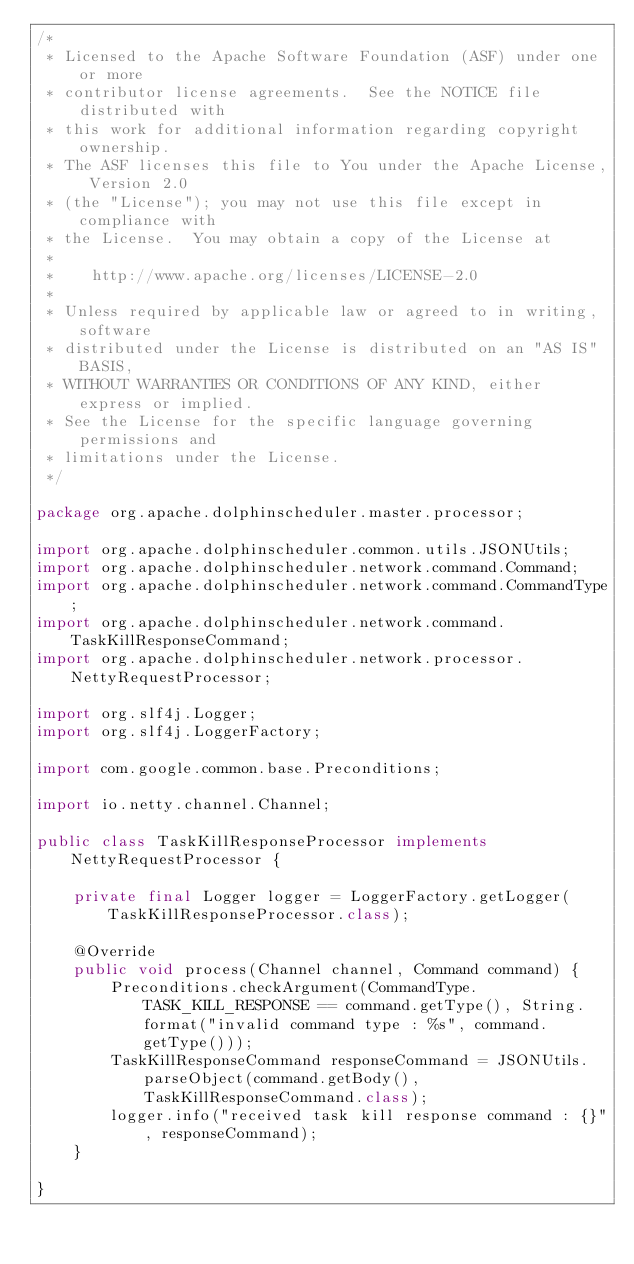<code> <loc_0><loc_0><loc_500><loc_500><_Java_>/*
 * Licensed to the Apache Software Foundation (ASF) under one or more
 * contributor license agreements.  See the NOTICE file distributed with
 * this work for additional information regarding copyright ownership.
 * The ASF licenses this file to You under the Apache License, Version 2.0
 * (the "License"); you may not use this file except in compliance with
 * the License.  You may obtain a copy of the License at
 *
 *    http://www.apache.org/licenses/LICENSE-2.0
 *
 * Unless required by applicable law or agreed to in writing, software
 * distributed under the License is distributed on an "AS IS" BASIS,
 * WITHOUT WARRANTIES OR CONDITIONS OF ANY KIND, either express or implied.
 * See the License for the specific language governing permissions and
 * limitations under the License.
 */

package org.apache.dolphinscheduler.master.processor;

import org.apache.dolphinscheduler.common.utils.JSONUtils;
import org.apache.dolphinscheduler.network.command.Command;
import org.apache.dolphinscheduler.network.command.CommandType;
import org.apache.dolphinscheduler.network.command.TaskKillResponseCommand;
import org.apache.dolphinscheduler.network.processor.NettyRequestProcessor;

import org.slf4j.Logger;
import org.slf4j.LoggerFactory;

import com.google.common.base.Preconditions;

import io.netty.channel.Channel;

public class TaskKillResponseProcessor implements NettyRequestProcessor {

    private final Logger logger = LoggerFactory.getLogger(TaskKillResponseProcessor.class);

    @Override
    public void process(Channel channel, Command command) {
        Preconditions.checkArgument(CommandType.TASK_KILL_RESPONSE == command.getType(), String.format("invalid command type : %s", command.getType()));
        TaskKillResponseCommand responseCommand = JSONUtils.parseObject(command.getBody(), TaskKillResponseCommand.class);
        logger.info("received task kill response command : {}", responseCommand);
    }

}
</code> 